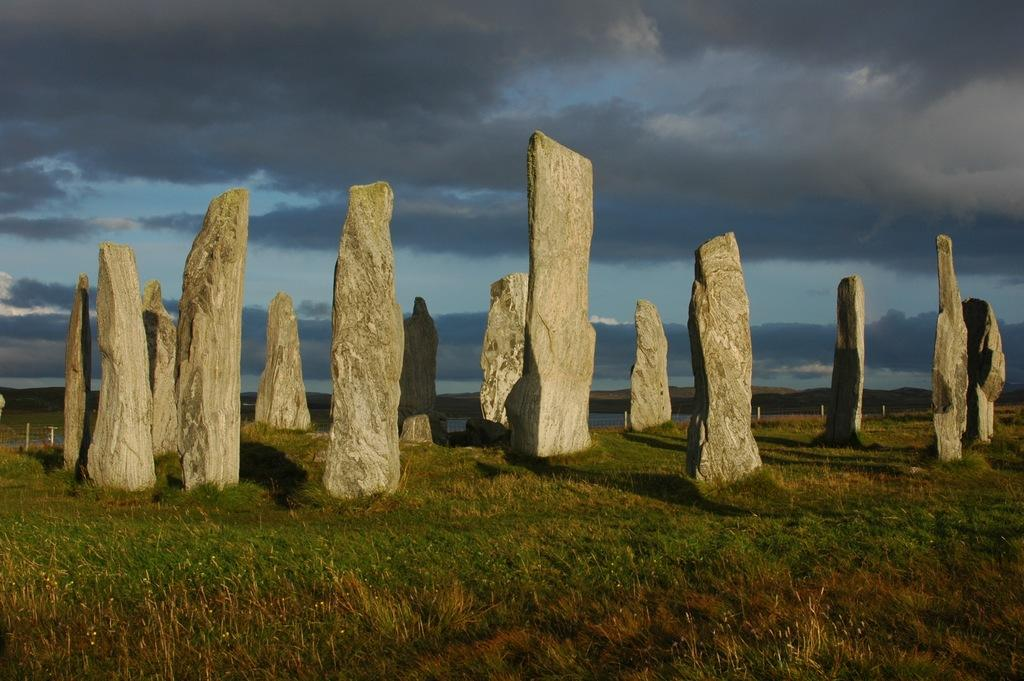What objects are on the grass in the image? There are stones on the grass in the image. What can be seen in the background of the image? Water, poles, mountains, and a cloudy sky are visible in the background of the image. What type of mitten is being used to sew the thread in the image? There is no mitten or thread present in the image. Who is the friend that is mentioned in the image? There is no mention of a friend in the image. 